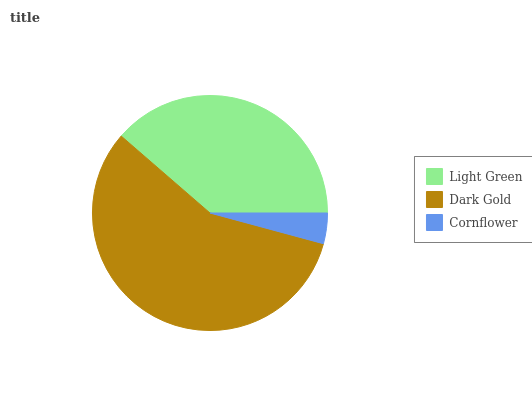Is Cornflower the minimum?
Answer yes or no. Yes. Is Dark Gold the maximum?
Answer yes or no. Yes. Is Dark Gold the minimum?
Answer yes or no. No. Is Cornflower the maximum?
Answer yes or no. No. Is Dark Gold greater than Cornflower?
Answer yes or no. Yes. Is Cornflower less than Dark Gold?
Answer yes or no. Yes. Is Cornflower greater than Dark Gold?
Answer yes or no. No. Is Dark Gold less than Cornflower?
Answer yes or no. No. Is Light Green the high median?
Answer yes or no. Yes. Is Light Green the low median?
Answer yes or no. Yes. Is Cornflower the high median?
Answer yes or no. No. Is Dark Gold the low median?
Answer yes or no. No. 